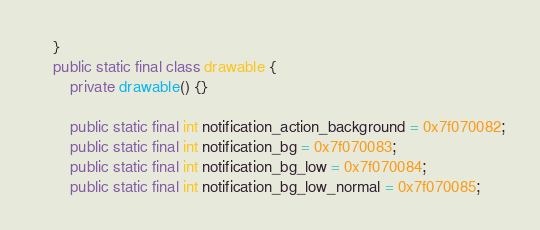Convert code to text. <code><loc_0><loc_0><loc_500><loc_500><_Java_>    }
    public static final class drawable {
        private drawable() {}

        public static final int notification_action_background = 0x7f070082;
        public static final int notification_bg = 0x7f070083;
        public static final int notification_bg_low = 0x7f070084;
        public static final int notification_bg_low_normal = 0x7f070085;</code> 